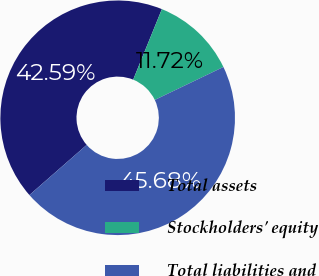Convert chart to OTSL. <chart><loc_0><loc_0><loc_500><loc_500><pie_chart><fcel>Total assets<fcel>Stockholders' equity<fcel>Total liabilities and<nl><fcel>42.59%<fcel>11.72%<fcel>45.68%<nl></chart> 